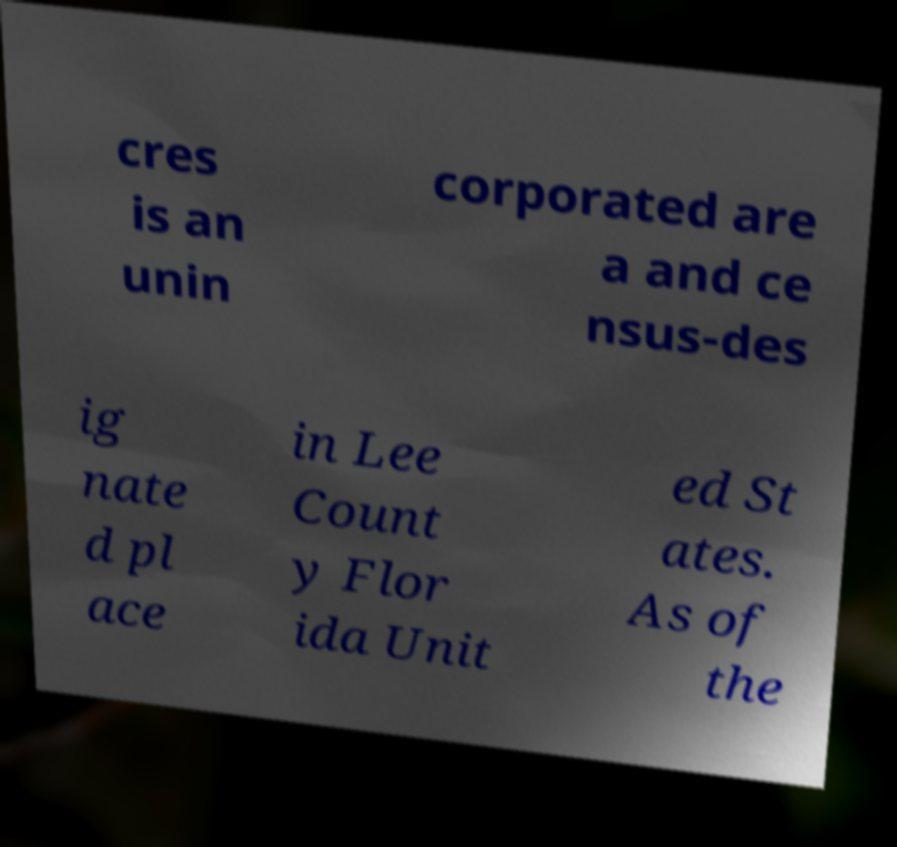Can you read and provide the text displayed in the image?This photo seems to have some interesting text. Can you extract and type it out for me? cres is an unin corporated are a and ce nsus-des ig nate d pl ace in Lee Count y Flor ida Unit ed St ates. As of the 